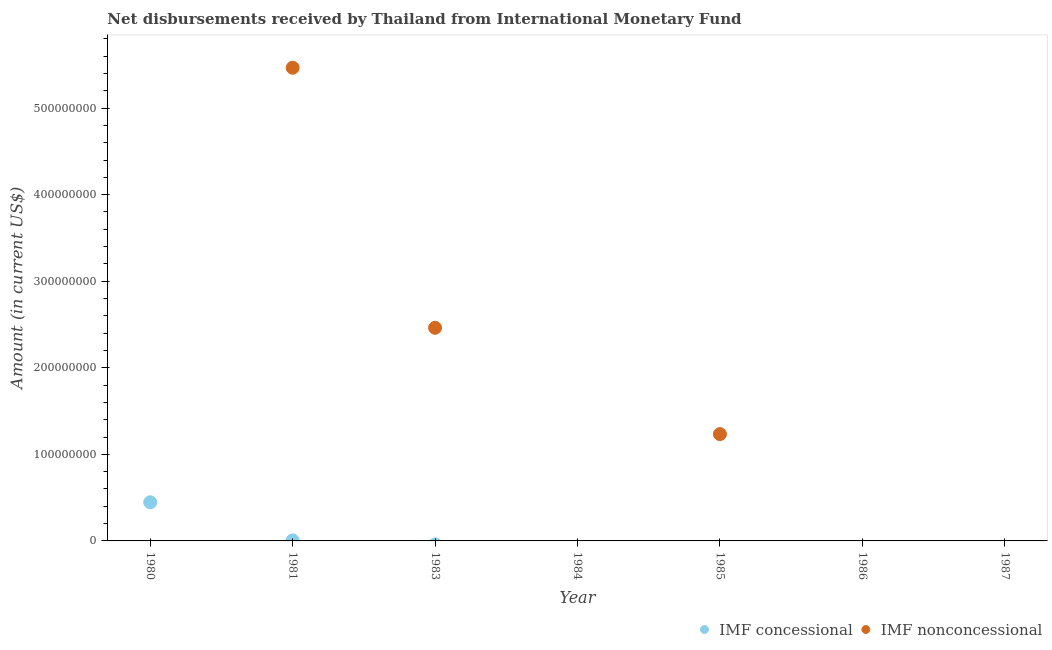How many different coloured dotlines are there?
Give a very brief answer. 2. Is the number of dotlines equal to the number of legend labels?
Your answer should be compact. No. Across all years, what is the maximum net non concessional disbursements from imf?
Give a very brief answer. 5.47e+08. In which year was the net non concessional disbursements from imf maximum?
Provide a succinct answer. 1981. What is the total net concessional disbursements from imf in the graph?
Ensure brevity in your answer.  4.52e+07. What is the average net concessional disbursements from imf per year?
Offer a terse response. 6.46e+06. In the year 1981, what is the difference between the net non concessional disbursements from imf and net concessional disbursements from imf?
Your response must be concise. 5.46e+08. In how many years, is the net concessional disbursements from imf greater than 420000000 US$?
Ensure brevity in your answer.  0. What is the difference between the highest and the second highest net non concessional disbursements from imf?
Your response must be concise. 3.00e+08. What is the difference between the highest and the lowest net non concessional disbursements from imf?
Offer a terse response. 5.47e+08. In how many years, is the net non concessional disbursements from imf greater than the average net non concessional disbursements from imf taken over all years?
Offer a terse response. 2. Is the net non concessional disbursements from imf strictly less than the net concessional disbursements from imf over the years?
Provide a short and direct response. No. How many dotlines are there?
Provide a short and direct response. 2. How many years are there in the graph?
Keep it short and to the point. 7. What is the difference between two consecutive major ticks on the Y-axis?
Ensure brevity in your answer.  1.00e+08. What is the title of the graph?
Provide a succinct answer. Net disbursements received by Thailand from International Monetary Fund. What is the Amount (in current US$) of IMF concessional in 1980?
Your answer should be compact. 4.46e+07. What is the Amount (in current US$) in IMF concessional in 1981?
Your answer should be compact. 5.97e+05. What is the Amount (in current US$) in IMF nonconcessional in 1981?
Ensure brevity in your answer.  5.47e+08. What is the Amount (in current US$) of IMF concessional in 1983?
Your answer should be very brief. 0. What is the Amount (in current US$) of IMF nonconcessional in 1983?
Make the answer very short. 2.46e+08. What is the Amount (in current US$) of IMF nonconcessional in 1984?
Keep it short and to the point. 0. What is the Amount (in current US$) in IMF nonconcessional in 1985?
Provide a succinct answer. 1.23e+08. What is the Amount (in current US$) of IMF concessional in 1986?
Your answer should be compact. 0. What is the Amount (in current US$) in IMF nonconcessional in 1986?
Offer a very short reply. 0. What is the Amount (in current US$) of IMF concessional in 1987?
Your answer should be very brief. 0. Across all years, what is the maximum Amount (in current US$) in IMF concessional?
Offer a terse response. 4.46e+07. Across all years, what is the maximum Amount (in current US$) of IMF nonconcessional?
Provide a succinct answer. 5.47e+08. Across all years, what is the minimum Amount (in current US$) of IMF concessional?
Ensure brevity in your answer.  0. Across all years, what is the minimum Amount (in current US$) of IMF nonconcessional?
Give a very brief answer. 0. What is the total Amount (in current US$) of IMF concessional in the graph?
Ensure brevity in your answer.  4.52e+07. What is the total Amount (in current US$) of IMF nonconcessional in the graph?
Your response must be concise. 9.16e+08. What is the difference between the Amount (in current US$) of IMF concessional in 1980 and that in 1981?
Your response must be concise. 4.41e+07. What is the difference between the Amount (in current US$) of IMF nonconcessional in 1981 and that in 1983?
Provide a short and direct response. 3.00e+08. What is the difference between the Amount (in current US$) of IMF nonconcessional in 1981 and that in 1985?
Offer a very short reply. 4.23e+08. What is the difference between the Amount (in current US$) in IMF nonconcessional in 1983 and that in 1985?
Offer a terse response. 1.23e+08. What is the difference between the Amount (in current US$) of IMF concessional in 1980 and the Amount (in current US$) of IMF nonconcessional in 1981?
Provide a short and direct response. -5.02e+08. What is the difference between the Amount (in current US$) of IMF concessional in 1980 and the Amount (in current US$) of IMF nonconcessional in 1983?
Provide a short and direct response. -2.02e+08. What is the difference between the Amount (in current US$) of IMF concessional in 1980 and the Amount (in current US$) of IMF nonconcessional in 1985?
Ensure brevity in your answer.  -7.87e+07. What is the difference between the Amount (in current US$) of IMF concessional in 1981 and the Amount (in current US$) of IMF nonconcessional in 1983?
Keep it short and to the point. -2.46e+08. What is the difference between the Amount (in current US$) in IMF concessional in 1981 and the Amount (in current US$) in IMF nonconcessional in 1985?
Your answer should be compact. -1.23e+08. What is the average Amount (in current US$) of IMF concessional per year?
Offer a terse response. 6.46e+06. What is the average Amount (in current US$) of IMF nonconcessional per year?
Provide a short and direct response. 1.31e+08. In the year 1981, what is the difference between the Amount (in current US$) of IMF concessional and Amount (in current US$) of IMF nonconcessional?
Ensure brevity in your answer.  -5.46e+08. What is the ratio of the Amount (in current US$) in IMF concessional in 1980 to that in 1981?
Make the answer very short. 74.79. What is the ratio of the Amount (in current US$) of IMF nonconcessional in 1981 to that in 1983?
Your answer should be compact. 2.22. What is the ratio of the Amount (in current US$) in IMF nonconcessional in 1981 to that in 1985?
Give a very brief answer. 4.43. What is the ratio of the Amount (in current US$) in IMF nonconcessional in 1983 to that in 1985?
Offer a very short reply. 2. What is the difference between the highest and the second highest Amount (in current US$) in IMF nonconcessional?
Provide a short and direct response. 3.00e+08. What is the difference between the highest and the lowest Amount (in current US$) in IMF concessional?
Your answer should be compact. 4.46e+07. What is the difference between the highest and the lowest Amount (in current US$) of IMF nonconcessional?
Make the answer very short. 5.47e+08. 